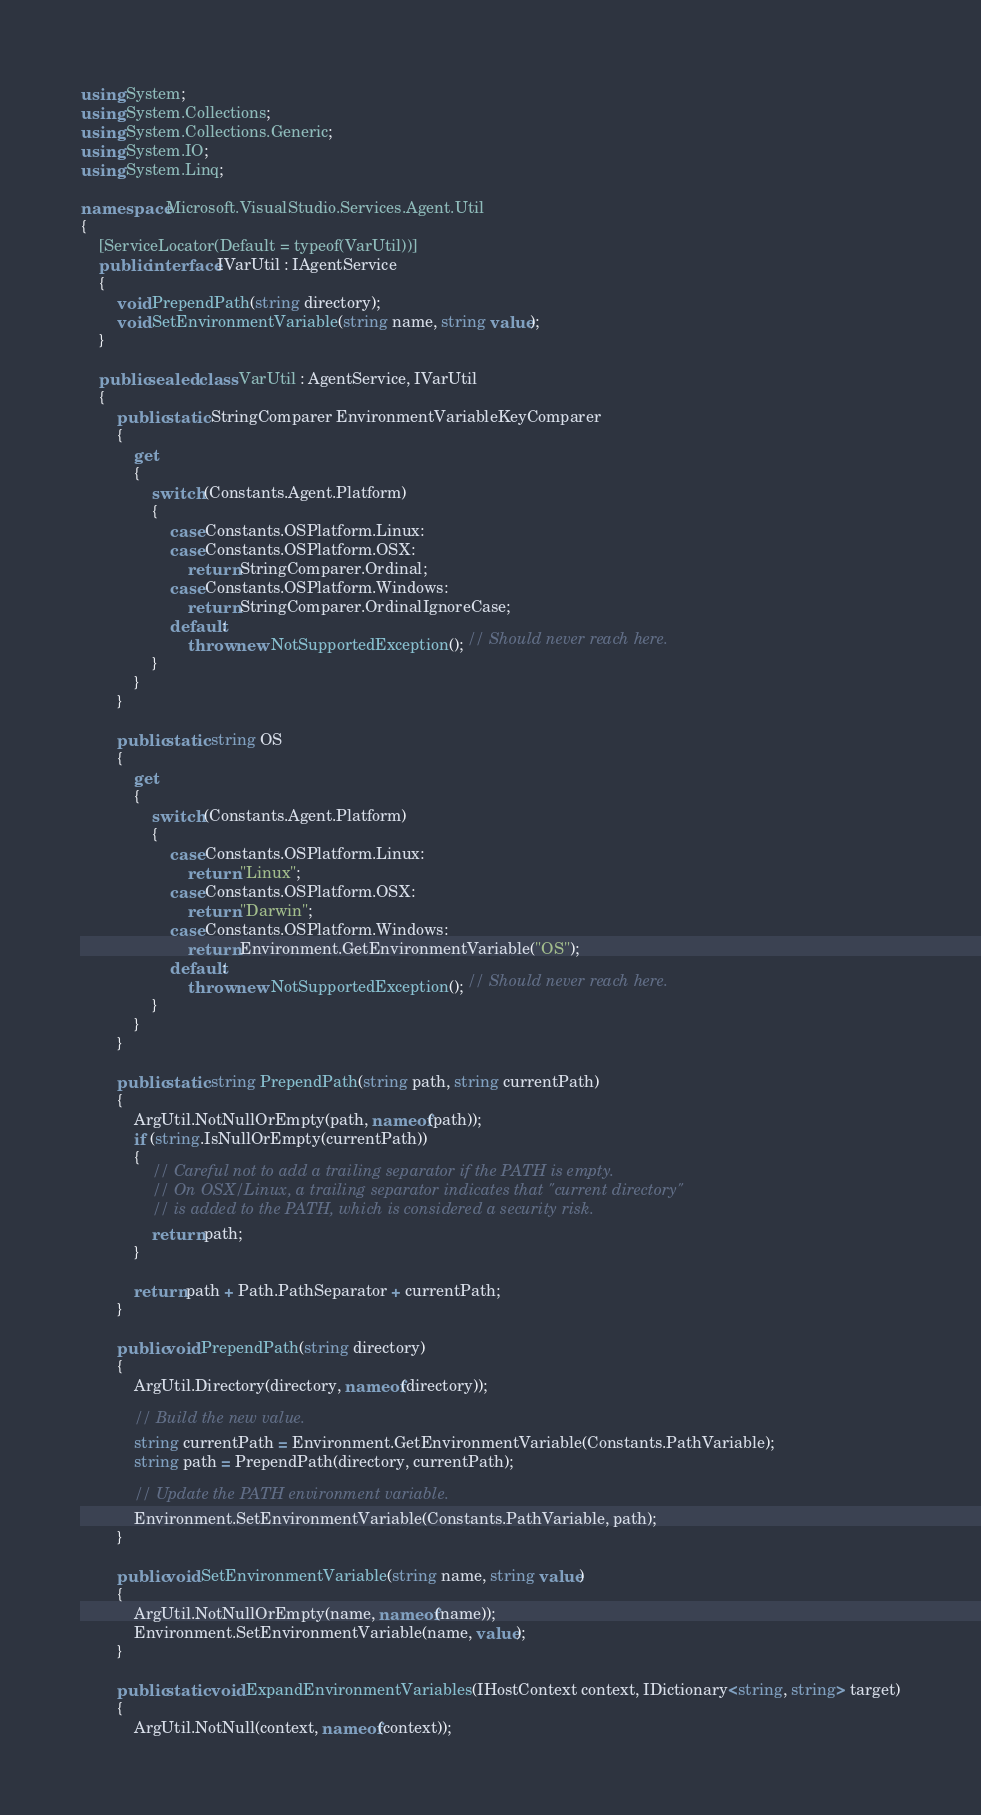Convert code to text. <code><loc_0><loc_0><loc_500><loc_500><_C#_>using System;
using System.Collections;
using System.Collections.Generic;
using System.IO;
using System.Linq;

namespace Microsoft.VisualStudio.Services.Agent.Util
{
    [ServiceLocator(Default = typeof(VarUtil))]
    public interface IVarUtil : IAgentService
    {
        void PrependPath(string directory);
        void SetEnvironmentVariable(string name, string value);
    }

    public sealed class VarUtil : AgentService, IVarUtil
    {
        public static StringComparer EnvironmentVariableKeyComparer
        {
            get
            {
                switch (Constants.Agent.Platform)
                {
                    case Constants.OSPlatform.Linux:
                    case Constants.OSPlatform.OSX:
                        return StringComparer.Ordinal;
                    case Constants.OSPlatform.Windows:
                        return StringComparer.OrdinalIgnoreCase;
                    default:
                        throw new NotSupportedException(); // Should never reach here.
                }
            }
        }

        public static string OS
        {
            get
            {
                switch (Constants.Agent.Platform)
                {
                    case Constants.OSPlatform.Linux:
                        return "Linux";
                    case Constants.OSPlatform.OSX:
                        return "Darwin";
                    case Constants.OSPlatform.Windows:
                        return Environment.GetEnvironmentVariable("OS");
                    default:
                        throw new NotSupportedException(); // Should never reach here.
                }
            }
        }

        public static string PrependPath(string path, string currentPath)
        {
            ArgUtil.NotNullOrEmpty(path, nameof(path));
            if (string.IsNullOrEmpty(currentPath))
            {
                // Careful not to add a trailing separator if the PATH is empty.
                // On OSX/Linux, a trailing separator indicates that "current directory"
                // is added to the PATH, which is considered a security risk.
                return path;
            }

            return path + Path.PathSeparator + currentPath;
        }

        public void PrependPath(string directory)
        {
            ArgUtil.Directory(directory, nameof(directory));

            // Build the new value.
            string currentPath = Environment.GetEnvironmentVariable(Constants.PathVariable);
            string path = PrependPath(directory, currentPath);

            // Update the PATH environment variable.
            Environment.SetEnvironmentVariable(Constants.PathVariable, path);
        }

        public void SetEnvironmentVariable(string name, string value)
        {
            ArgUtil.NotNullOrEmpty(name, nameof(name));
            Environment.SetEnvironmentVariable(name, value);
        }

        public static void ExpandEnvironmentVariables(IHostContext context, IDictionary<string, string> target)
        {
            ArgUtil.NotNull(context, nameof(context));</code> 